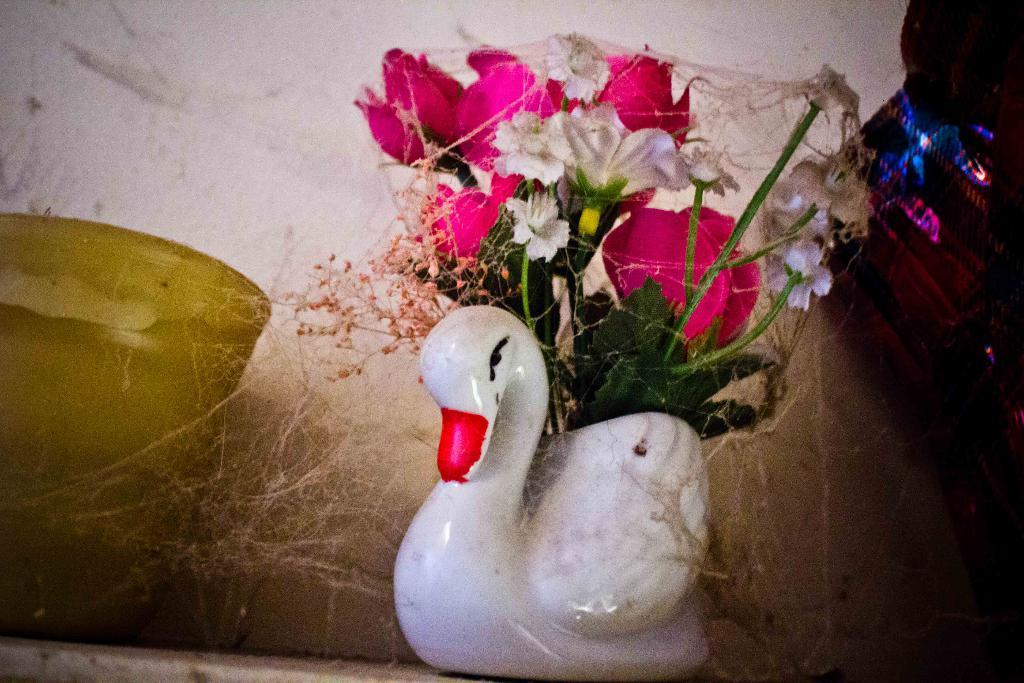What is the main object in the center of the image? There is a flower vase in the center of the image. What can be seen in the background of the image? There is a wall in the background of the image. Are there any other objects related to flowers in the image? Yes, there is a flower pot in the image. What type of frame is around the flower vase in the image? There is no frame around the flower vase in the image. Can you tell me how many aunts are present in the image? There are no people, including aunts, present in the image. 